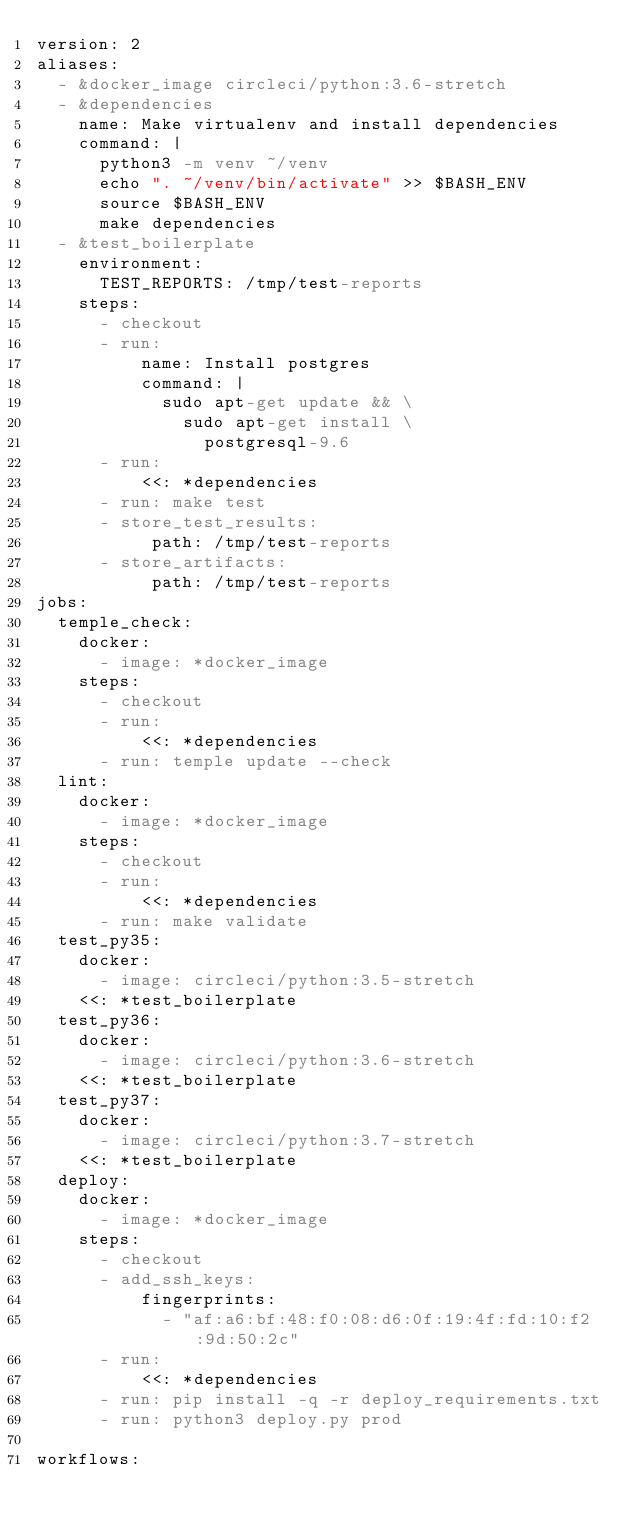Convert code to text. <code><loc_0><loc_0><loc_500><loc_500><_YAML_>version: 2
aliases:
  - &docker_image circleci/python:3.6-stretch
  - &dependencies
    name: Make virtualenv and install dependencies
    command: |
      python3 -m venv ~/venv
      echo ". ~/venv/bin/activate" >> $BASH_ENV
      source $BASH_ENV
      make dependencies
  - &test_boilerplate
    environment:
      TEST_REPORTS: /tmp/test-reports
    steps:
      - checkout
      - run:
          name: Install postgres
          command: |
            sudo apt-get update && \
              sudo apt-get install \
                postgresql-9.6
      - run:
          <<: *dependencies
      - run: make test
      - store_test_results:
           path: /tmp/test-reports
      - store_artifacts:
           path: /tmp/test-reports
jobs:
  temple_check:
    docker:
      - image: *docker_image
    steps:
      - checkout
      - run:
          <<: *dependencies
      - run: temple update --check
  lint:
    docker:
      - image: *docker_image
    steps:
      - checkout
      - run:
          <<: *dependencies
      - run: make validate
  test_py35:
    docker:
      - image: circleci/python:3.5-stretch
    <<: *test_boilerplate
  test_py36:
    docker:
      - image: circleci/python:3.6-stretch
    <<: *test_boilerplate
  test_py37:
    docker:
      - image: circleci/python:3.7-stretch
    <<: *test_boilerplate
  deploy:
    docker:
      - image: *docker_image
    steps:
      - checkout
      - add_ssh_keys:
          fingerprints:
            - "af:a6:bf:48:f0:08:d6:0f:19:4f:fd:10:f2:9d:50:2c"
      - run:
          <<: *dependencies
      - run: pip install -q -r deploy_requirements.txt
      - run: python3 deploy.py prod

workflows:</code> 